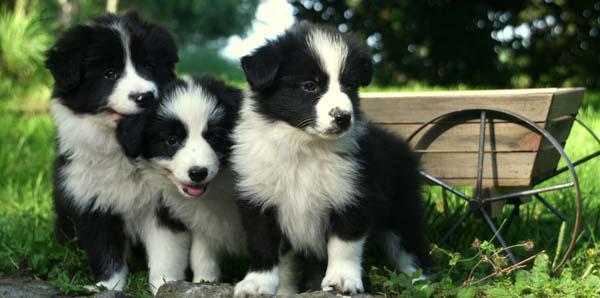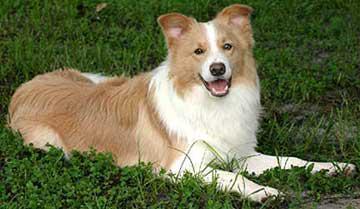The first image is the image on the left, the second image is the image on the right. Evaluate the accuracy of this statement regarding the images: "The dog in the image on the right is laying down with their face pointing forward.". Is it true? Answer yes or no. Yes. The first image is the image on the left, the second image is the image on the right. For the images shown, is this caption "There are three dogs in one picture and one dog in the other picture." true? Answer yes or no. Yes. 